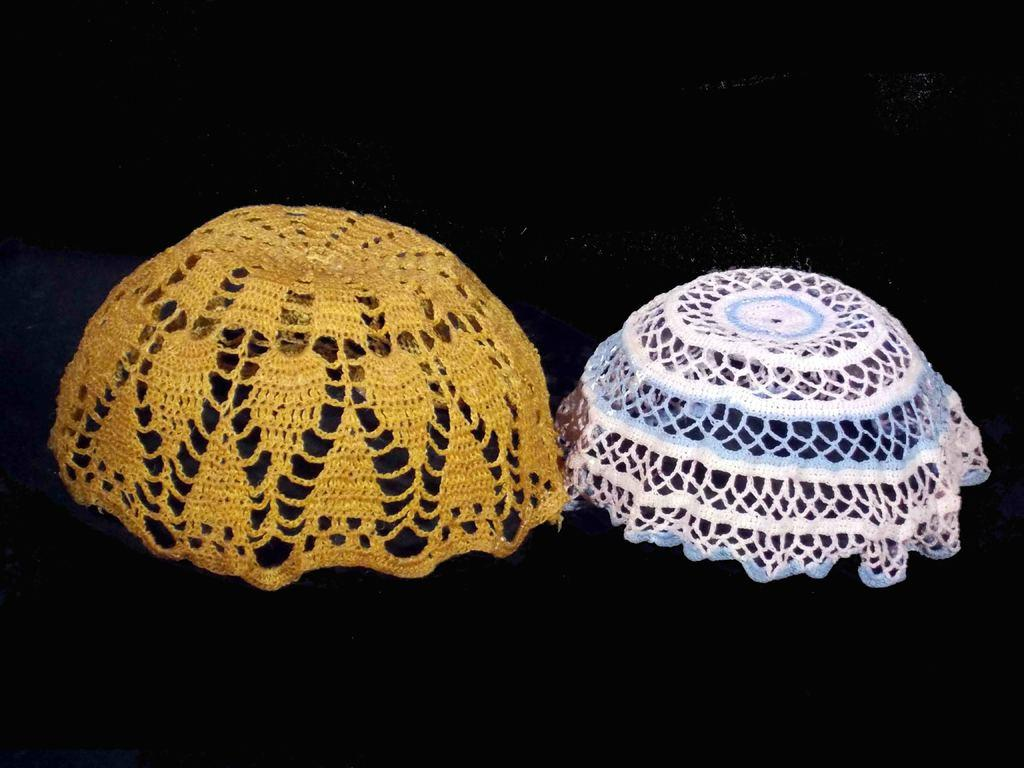What type of objects are in the image? There are woven baskets in the image. What is the color of the surface on which the baskets are placed? The baskets are on a black surface. What type of power source can be seen in the image? There is no power source visible in the image; it features woven baskets on a black surface. How many snakes are slithering around the baskets in the image? There are no snakes present in the image. 